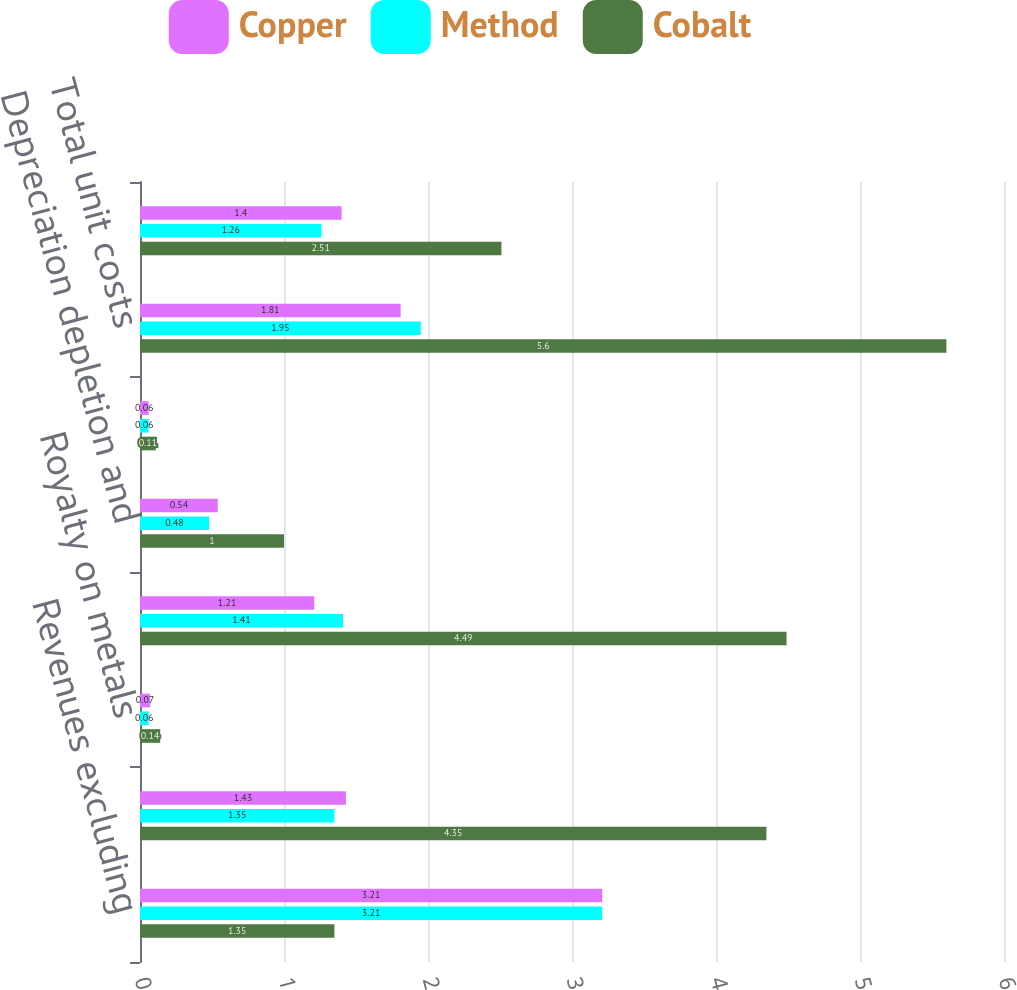Convert chart. <chart><loc_0><loc_0><loc_500><loc_500><stacked_bar_chart><ecel><fcel>Revenues excluding<fcel>and other costs shown below<fcel>Royalty on metals<fcel>Unit net cash costs<fcel>Depreciation depletion and<fcel>Noncash and other costs net<fcel>Total unit costs<fcel>Gross profit per pound<nl><fcel>Copper<fcel>3.21<fcel>1.43<fcel>0.07<fcel>1.21<fcel>0.54<fcel>0.06<fcel>1.81<fcel>1.4<nl><fcel>Method<fcel>3.21<fcel>1.35<fcel>0.06<fcel>1.41<fcel>0.48<fcel>0.06<fcel>1.95<fcel>1.26<nl><fcel>Cobalt<fcel>1.35<fcel>4.35<fcel>0.14<fcel>4.49<fcel>1<fcel>0.11<fcel>5.6<fcel>2.51<nl></chart> 